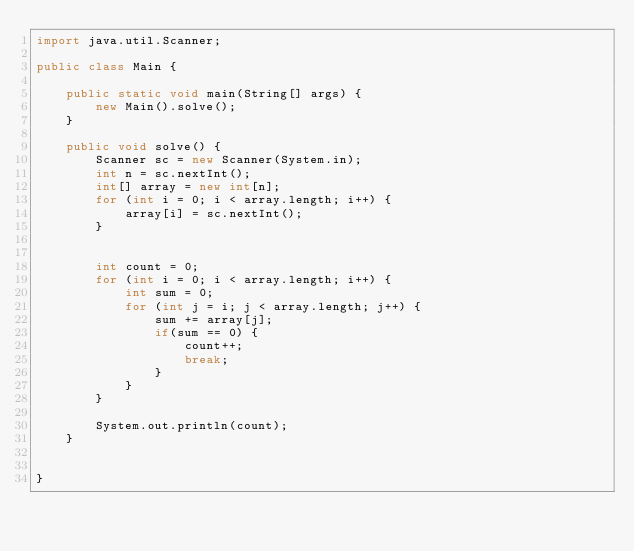Convert code to text. <code><loc_0><loc_0><loc_500><loc_500><_Java_>import java.util.Scanner;

public class Main {

    public static void main(String[] args) {
        new Main().solve();
    }

    public void solve() {
        Scanner sc = new Scanner(System.in);
        int n = sc.nextInt();
        int[] array = new int[n];
        for (int i = 0; i < array.length; i++) {
            array[i] = sc.nextInt();
        }


        int count = 0;
        for (int i = 0; i < array.length; i++) {
            int sum = 0;
            for (int j = i; j < array.length; j++) {
                sum += array[j];
                if(sum == 0) {
                    count++;
                    break;
                }
            }
        }

        System.out.println(count);
    }


}
</code> 